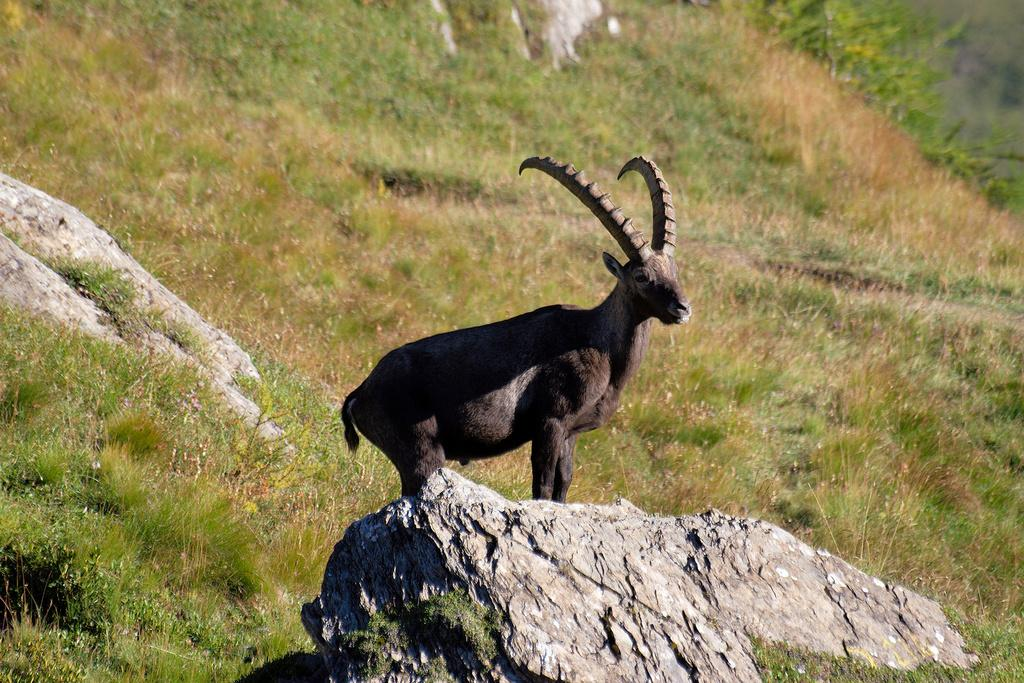What type of setting is depicted in the image? The image is an outside view. What can be seen at the bottom of the image? There is a rock at the bottom of the image. What kind of living creature is in the image? There is an animal in the image. What type of vegetation is visible in the background of the image? Grass and plants are present in the background of the image. Can you describe another feature in the image? There is another rock on the left side of the image. What type of rhythm does the skate have in the image? There is no skate present in the image, so it is not possible to determine its rhythm. 